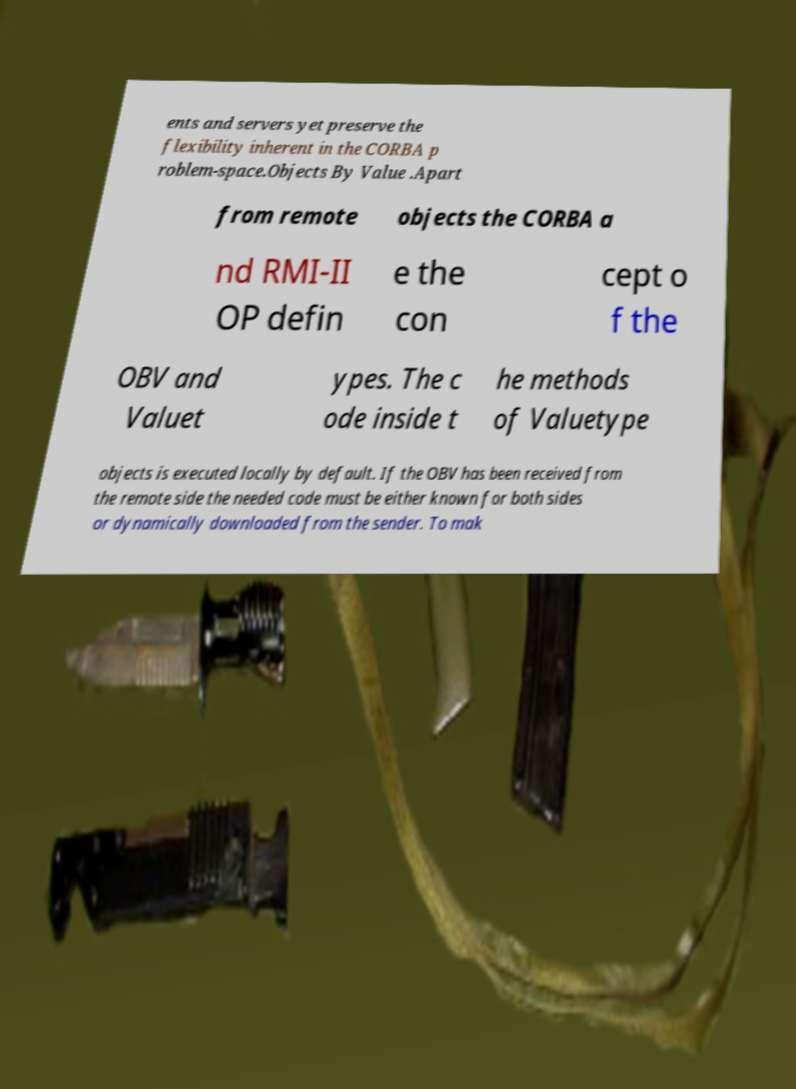Can you read and provide the text displayed in the image?This photo seems to have some interesting text. Can you extract and type it out for me? ents and servers yet preserve the flexibility inherent in the CORBA p roblem-space.Objects By Value .Apart from remote objects the CORBA a nd RMI-II OP defin e the con cept o f the OBV and Valuet ypes. The c ode inside t he methods of Valuetype objects is executed locally by default. If the OBV has been received from the remote side the needed code must be either known for both sides or dynamically downloaded from the sender. To mak 